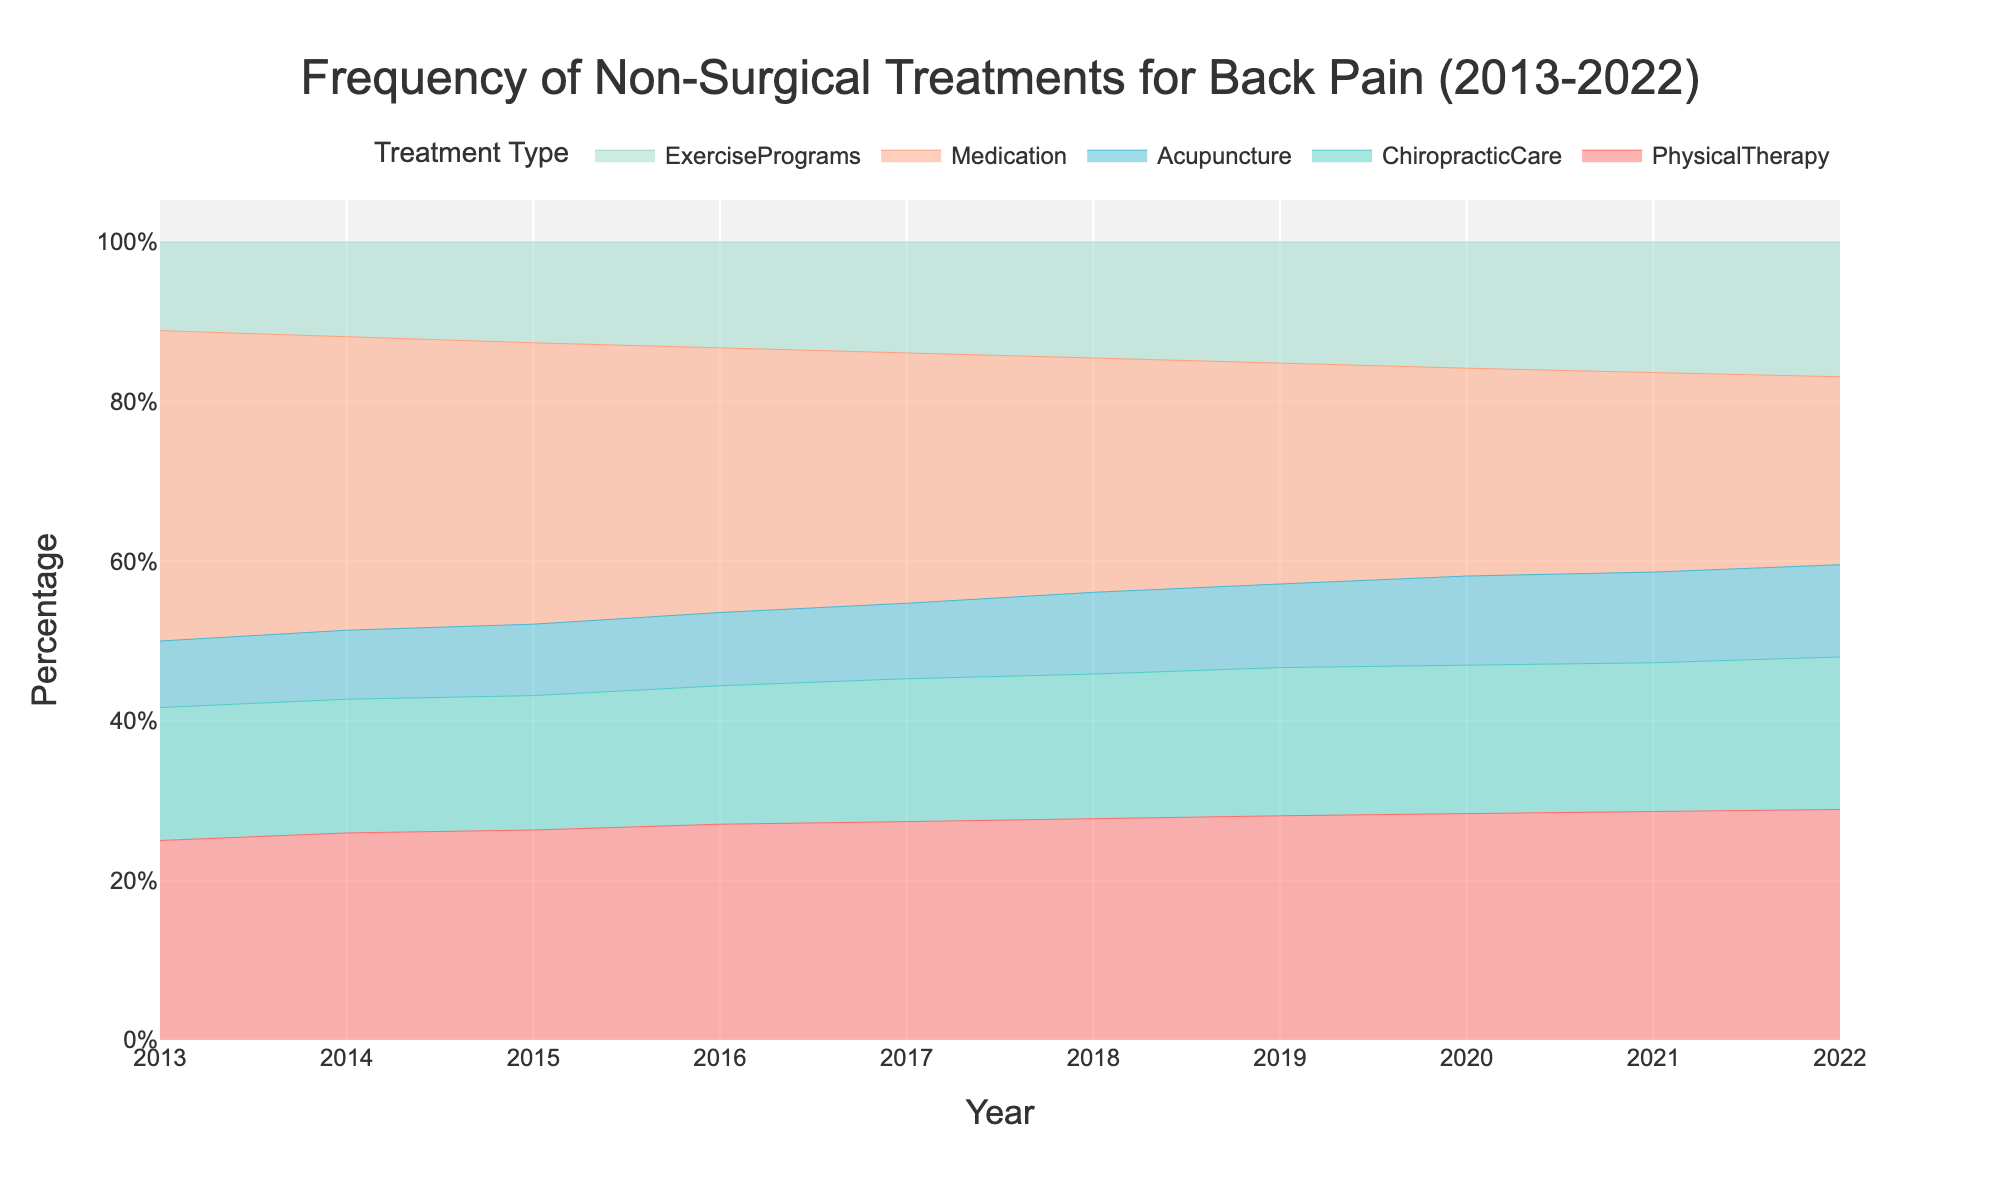what is the title of the chart? The title is usually located at the top of the chart. In this case, it reads "Frequency of Non-Surgical Treatments for Back Pain (2013-2022)."
Answer: Frequency of Non-Surgical Treatments for Back Pain (2013-2022) How many treatments are represented in the chart? The chart lists all the treatments in the legend. The legend includes Physical Therapy, Chiropractic Care, Acupuncture, Medication, and Exercise Programs.
Answer: Five Which treatment has consistently decreased from 2013 to 2022? The y-axis values need to be examined over the years to find a decreasing trend. Medication is the only treatment whose frequency values decrease from 70 in 2013 to 53 in 2022.
Answer: Medication What is the frequency of Physical Therapy in 2019? Look at the colored area corresponding to Physical Therapy's color (red) in 2019. The chart shows that Physical Therapy has a value of 59% in 2019.
Answer: 59% Which treatment shows the highest increase from 2013 to 2022? Calculate the difference between the values in 2013 and 2022 for all treatments. Physical Therapy increases from 45 to 65, a difference of 20, which is the highest.
Answer: Physical Therapy How do the frequencies of Acupuncture and Chiropractic Care compare in 2020? Look at the y-values for Acupuncture and Chiropractic Care in 2020. Acupuncture is at 24% and Chiropractic Care is at 40%.
Answer: Chiropractic Care has higher frequency than Acupuncture In which year did Exercise Programs reach a frequency of 30%? Look for when the Exercise Programs' area reaches the 30% mark. In 2018, Exercise Programs have a frequency of 30%.
Answer: In 2018 Across the decade, which treatment has remained relatively stable? Examine which treatment shows the least variation from year to year. Chiropractic Care shows only a gradual increase with less fluctuation compared to others.
Answer: Chiropractic Care What was the percentage change for Exercise Programs from 2013 to 2022? Calculate the difference between 2022 and 2013 values, then divide by the 2013 value, and multiply by 100. (38-20)/20 * 100 = 90%
Answer: 90% Which two treatments had nearly equal frequencies in 2022? Compare the final data points for all treatments. In 2022, Acupuncture (26%) and Chiropractic Care (43%) are not equal, but absolute values show that closer values were found in earlier years like 2016 with Acupuncture(18%) and Chiropractic Care(34%).
Answer: None in 2022 